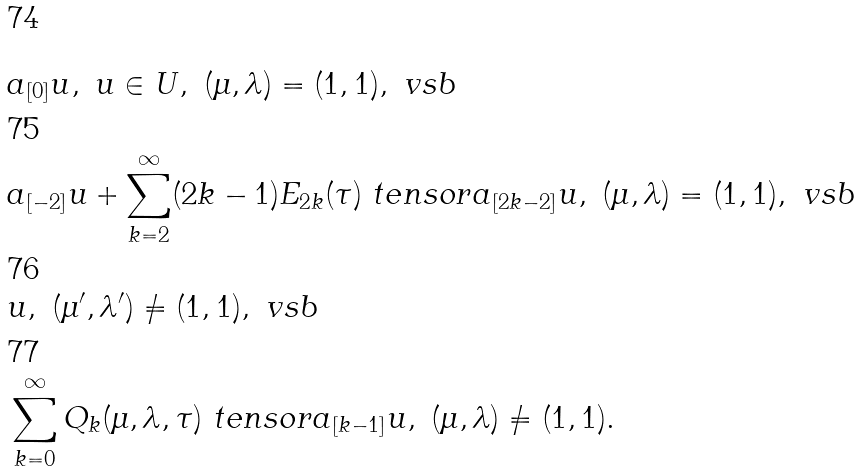Convert formula to latex. <formula><loc_0><loc_0><loc_500><loc_500>& a _ { [ 0 ] } u , \ u \in U , \ ( \mu , \lambda ) = ( 1 , 1 ) , \ v s b \\ & a _ { [ - 2 ] } u + \sum _ { k = 2 } ^ { \infty } ( 2 k - 1 ) E _ { 2 k } ( \tau ) \ t e n s o r a _ { [ 2 k - 2 ] } u , \ ( \mu , \lambda ) = ( 1 , 1 ) , \ v s b \\ & u , \ ( \mu ^ { \prime } , \lambda ^ { \prime } ) \ne ( 1 , 1 ) , \ v s b \\ & \sum _ { k = 0 } ^ { \infty } Q _ { k } ( \mu , \lambda , \tau ) \ t e n s o r a _ { [ k - 1 ] } u , \ ( \mu , \lambda ) \ne ( 1 , 1 ) .</formula> 